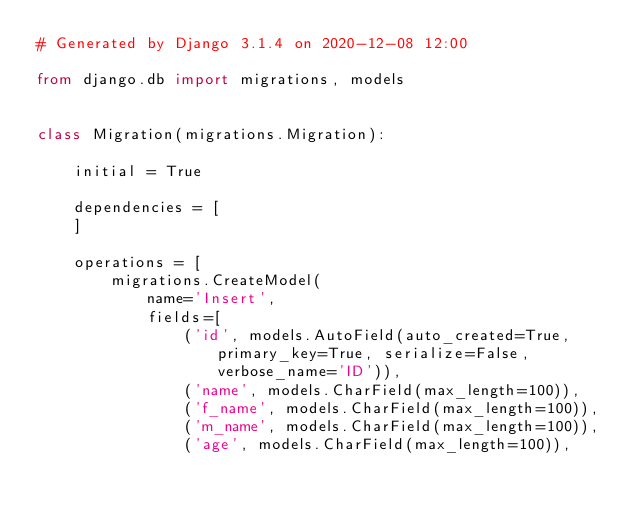Convert code to text. <code><loc_0><loc_0><loc_500><loc_500><_Python_># Generated by Django 3.1.4 on 2020-12-08 12:00

from django.db import migrations, models


class Migration(migrations.Migration):

    initial = True

    dependencies = [
    ]

    operations = [
        migrations.CreateModel(
            name='Insert',
            fields=[
                ('id', models.AutoField(auto_created=True, primary_key=True, serialize=False, verbose_name='ID')),
                ('name', models.CharField(max_length=100)),
                ('f_name', models.CharField(max_length=100)),
                ('m_name', models.CharField(max_length=100)),
                ('age', models.CharField(max_length=100)),</code> 